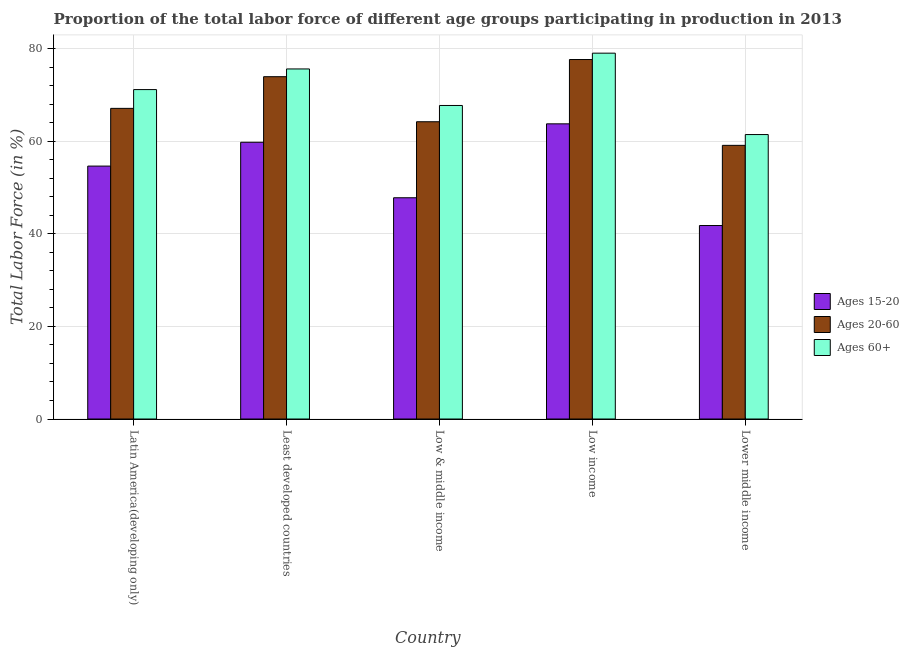Are the number of bars per tick equal to the number of legend labels?
Offer a terse response. Yes. How many bars are there on the 2nd tick from the left?
Ensure brevity in your answer.  3. In how many cases, is the number of bars for a given country not equal to the number of legend labels?
Give a very brief answer. 0. What is the percentage of labor force within the age group 15-20 in Lower middle income?
Keep it short and to the point. 41.79. Across all countries, what is the maximum percentage of labor force above age 60?
Make the answer very short. 79.02. Across all countries, what is the minimum percentage of labor force within the age group 15-20?
Keep it short and to the point. 41.79. In which country was the percentage of labor force within the age group 15-20 maximum?
Ensure brevity in your answer.  Low income. In which country was the percentage of labor force above age 60 minimum?
Provide a short and direct response. Lower middle income. What is the total percentage of labor force within the age group 20-60 in the graph?
Offer a very short reply. 341.98. What is the difference between the percentage of labor force within the age group 20-60 in Latin America(developing only) and that in Low income?
Ensure brevity in your answer.  -10.55. What is the difference between the percentage of labor force within the age group 15-20 in Latin America(developing only) and the percentage of labor force within the age group 20-60 in Low & middle income?
Make the answer very short. -9.58. What is the average percentage of labor force within the age group 15-20 per country?
Make the answer very short. 53.55. What is the difference between the percentage of labor force within the age group 20-60 and percentage of labor force within the age group 15-20 in Lower middle income?
Offer a very short reply. 17.31. What is the ratio of the percentage of labor force within the age group 20-60 in Least developed countries to that in Low & middle income?
Your answer should be compact. 1.15. What is the difference between the highest and the second highest percentage of labor force within the age group 15-20?
Provide a short and direct response. 3.98. What is the difference between the highest and the lowest percentage of labor force above age 60?
Provide a short and direct response. 17.58. Is the sum of the percentage of labor force within the age group 15-20 in Low & middle income and Lower middle income greater than the maximum percentage of labor force within the age group 20-60 across all countries?
Give a very brief answer. Yes. What does the 2nd bar from the left in Low & middle income represents?
Make the answer very short. Ages 20-60. What does the 3rd bar from the right in Low & middle income represents?
Make the answer very short. Ages 15-20. Are all the bars in the graph horizontal?
Ensure brevity in your answer.  No. Are the values on the major ticks of Y-axis written in scientific E-notation?
Your answer should be very brief. No. Does the graph contain grids?
Your answer should be compact. Yes. Where does the legend appear in the graph?
Offer a very short reply. Center right. What is the title of the graph?
Your answer should be very brief. Proportion of the total labor force of different age groups participating in production in 2013. What is the label or title of the Y-axis?
Give a very brief answer. Total Labor Force (in %). What is the Total Labor Force (in %) in Ages 15-20 in Latin America(developing only)?
Your answer should be compact. 54.63. What is the Total Labor Force (in %) of Ages 20-60 in Latin America(developing only)?
Keep it short and to the point. 67.1. What is the Total Labor Force (in %) of Ages 60+ in Latin America(developing only)?
Your answer should be compact. 71.15. What is the Total Labor Force (in %) in Ages 15-20 in Least developed countries?
Your answer should be very brief. 59.77. What is the Total Labor Force (in %) in Ages 20-60 in Least developed countries?
Your answer should be compact. 73.93. What is the Total Labor Force (in %) in Ages 60+ in Least developed countries?
Offer a very short reply. 75.61. What is the Total Labor Force (in %) in Ages 15-20 in Low & middle income?
Your answer should be compact. 47.79. What is the Total Labor Force (in %) of Ages 20-60 in Low & middle income?
Ensure brevity in your answer.  64.2. What is the Total Labor Force (in %) of Ages 60+ in Low & middle income?
Provide a succinct answer. 67.72. What is the Total Labor Force (in %) of Ages 15-20 in Low income?
Give a very brief answer. 63.75. What is the Total Labor Force (in %) in Ages 20-60 in Low income?
Offer a terse response. 77.64. What is the Total Labor Force (in %) in Ages 60+ in Low income?
Provide a short and direct response. 79.02. What is the Total Labor Force (in %) in Ages 15-20 in Lower middle income?
Ensure brevity in your answer.  41.79. What is the Total Labor Force (in %) of Ages 20-60 in Lower middle income?
Provide a succinct answer. 59.11. What is the Total Labor Force (in %) in Ages 60+ in Lower middle income?
Your response must be concise. 61.44. Across all countries, what is the maximum Total Labor Force (in %) in Ages 15-20?
Make the answer very short. 63.75. Across all countries, what is the maximum Total Labor Force (in %) of Ages 20-60?
Provide a succinct answer. 77.64. Across all countries, what is the maximum Total Labor Force (in %) in Ages 60+?
Provide a short and direct response. 79.02. Across all countries, what is the minimum Total Labor Force (in %) of Ages 15-20?
Your answer should be very brief. 41.79. Across all countries, what is the minimum Total Labor Force (in %) in Ages 20-60?
Make the answer very short. 59.11. Across all countries, what is the minimum Total Labor Force (in %) of Ages 60+?
Provide a short and direct response. 61.44. What is the total Total Labor Force (in %) of Ages 15-20 in the graph?
Provide a short and direct response. 267.73. What is the total Total Labor Force (in %) of Ages 20-60 in the graph?
Your response must be concise. 341.98. What is the total Total Labor Force (in %) of Ages 60+ in the graph?
Your response must be concise. 354.93. What is the difference between the Total Labor Force (in %) in Ages 15-20 in Latin America(developing only) and that in Least developed countries?
Your answer should be very brief. -5.15. What is the difference between the Total Labor Force (in %) in Ages 20-60 in Latin America(developing only) and that in Least developed countries?
Your answer should be very brief. -6.84. What is the difference between the Total Labor Force (in %) of Ages 60+ in Latin America(developing only) and that in Least developed countries?
Provide a short and direct response. -4.46. What is the difference between the Total Labor Force (in %) of Ages 15-20 in Latin America(developing only) and that in Low & middle income?
Provide a succinct answer. 6.84. What is the difference between the Total Labor Force (in %) of Ages 20-60 in Latin America(developing only) and that in Low & middle income?
Offer a terse response. 2.89. What is the difference between the Total Labor Force (in %) in Ages 60+ in Latin America(developing only) and that in Low & middle income?
Provide a short and direct response. 3.43. What is the difference between the Total Labor Force (in %) in Ages 15-20 in Latin America(developing only) and that in Low income?
Ensure brevity in your answer.  -9.12. What is the difference between the Total Labor Force (in %) of Ages 20-60 in Latin America(developing only) and that in Low income?
Keep it short and to the point. -10.55. What is the difference between the Total Labor Force (in %) of Ages 60+ in Latin America(developing only) and that in Low income?
Provide a succinct answer. -7.87. What is the difference between the Total Labor Force (in %) of Ages 15-20 in Latin America(developing only) and that in Lower middle income?
Offer a terse response. 12.84. What is the difference between the Total Labor Force (in %) in Ages 20-60 in Latin America(developing only) and that in Lower middle income?
Provide a succinct answer. 7.99. What is the difference between the Total Labor Force (in %) in Ages 60+ in Latin America(developing only) and that in Lower middle income?
Your response must be concise. 9.71. What is the difference between the Total Labor Force (in %) of Ages 15-20 in Least developed countries and that in Low & middle income?
Your answer should be compact. 11.99. What is the difference between the Total Labor Force (in %) of Ages 20-60 in Least developed countries and that in Low & middle income?
Provide a succinct answer. 9.73. What is the difference between the Total Labor Force (in %) of Ages 60+ in Least developed countries and that in Low & middle income?
Offer a very short reply. 7.89. What is the difference between the Total Labor Force (in %) of Ages 15-20 in Least developed countries and that in Low income?
Your answer should be compact. -3.98. What is the difference between the Total Labor Force (in %) in Ages 20-60 in Least developed countries and that in Low income?
Your response must be concise. -3.71. What is the difference between the Total Labor Force (in %) of Ages 60+ in Least developed countries and that in Low income?
Ensure brevity in your answer.  -3.41. What is the difference between the Total Labor Force (in %) in Ages 15-20 in Least developed countries and that in Lower middle income?
Ensure brevity in your answer.  17.98. What is the difference between the Total Labor Force (in %) in Ages 20-60 in Least developed countries and that in Lower middle income?
Provide a succinct answer. 14.83. What is the difference between the Total Labor Force (in %) in Ages 60+ in Least developed countries and that in Lower middle income?
Offer a very short reply. 14.17. What is the difference between the Total Labor Force (in %) of Ages 15-20 in Low & middle income and that in Low income?
Offer a very short reply. -15.96. What is the difference between the Total Labor Force (in %) in Ages 20-60 in Low & middle income and that in Low income?
Provide a short and direct response. -13.44. What is the difference between the Total Labor Force (in %) of Ages 60+ in Low & middle income and that in Low income?
Offer a very short reply. -11.3. What is the difference between the Total Labor Force (in %) in Ages 15-20 in Low & middle income and that in Lower middle income?
Offer a terse response. 6. What is the difference between the Total Labor Force (in %) in Ages 20-60 in Low & middle income and that in Lower middle income?
Offer a very short reply. 5.1. What is the difference between the Total Labor Force (in %) in Ages 60+ in Low & middle income and that in Lower middle income?
Your answer should be compact. 6.28. What is the difference between the Total Labor Force (in %) in Ages 15-20 in Low income and that in Lower middle income?
Your response must be concise. 21.96. What is the difference between the Total Labor Force (in %) in Ages 20-60 in Low income and that in Lower middle income?
Your answer should be very brief. 18.54. What is the difference between the Total Labor Force (in %) of Ages 60+ in Low income and that in Lower middle income?
Offer a very short reply. 17.58. What is the difference between the Total Labor Force (in %) of Ages 15-20 in Latin America(developing only) and the Total Labor Force (in %) of Ages 20-60 in Least developed countries?
Provide a short and direct response. -19.31. What is the difference between the Total Labor Force (in %) of Ages 15-20 in Latin America(developing only) and the Total Labor Force (in %) of Ages 60+ in Least developed countries?
Make the answer very short. -20.98. What is the difference between the Total Labor Force (in %) in Ages 20-60 in Latin America(developing only) and the Total Labor Force (in %) in Ages 60+ in Least developed countries?
Ensure brevity in your answer.  -8.51. What is the difference between the Total Labor Force (in %) in Ages 15-20 in Latin America(developing only) and the Total Labor Force (in %) in Ages 20-60 in Low & middle income?
Your answer should be compact. -9.58. What is the difference between the Total Labor Force (in %) of Ages 15-20 in Latin America(developing only) and the Total Labor Force (in %) of Ages 60+ in Low & middle income?
Make the answer very short. -13.09. What is the difference between the Total Labor Force (in %) of Ages 20-60 in Latin America(developing only) and the Total Labor Force (in %) of Ages 60+ in Low & middle income?
Offer a terse response. -0.62. What is the difference between the Total Labor Force (in %) of Ages 15-20 in Latin America(developing only) and the Total Labor Force (in %) of Ages 20-60 in Low income?
Provide a short and direct response. -23.02. What is the difference between the Total Labor Force (in %) of Ages 15-20 in Latin America(developing only) and the Total Labor Force (in %) of Ages 60+ in Low income?
Offer a very short reply. -24.39. What is the difference between the Total Labor Force (in %) of Ages 20-60 in Latin America(developing only) and the Total Labor Force (in %) of Ages 60+ in Low income?
Keep it short and to the point. -11.92. What is the difference between the Total Labor Force (in %) of Ages 15-20 in Latin America(developing only) and the Total Labor Force (in %) of Ages 20-60 in Lower middle income?
Give a very brief answer. -4.48. What is the difference between the Total Labor Force (in %) in Ages 15-20 in Latin America(developing only) and the Total Labor Force (in %) in Ages 60+ in Lower middle income?
Your answer should be compact. -6.81. What is the difference between the Total Labor Force (in %) of Ages 20-60 in Latin America(developing only) and the Total Labor Force (in %) of Ages 60+ in Lower middle income?
Offer a very short reply. 5.66. What is the difference between the Total Labor Force (in %) of Ages 15-20 in Least developed countries and the Total Labor Force (in %) of Ages 20-60 in Low & middle income?
Give a very brief answer. -4.43. What is the difference between the Total Labor Force (in %) in Ages 15-20 in Least developed countries and the Total Labor Force (in %) in Ages 60+ in Low & middle income?
Your answer should be compact. -7.94. What is the difference between the Total Labor Force (in %) in Ages 20-60 in Least developed countries and the Total Labor Force (in %) in Ages 60+ in Low & middle income?
Your answer should be compact. 6.22. What is the difference between the Total Labor Force (in %) of Ages 15-20 in Least developed countries and the Total Labor Force (in %) of Ages 20-60 in Low income?
Offer a terse response. -17.87. What is the difference between the Total Labor Force (in %) of Ages 15-20 in Least developed countries and the Total Labor Force (in %) of Ages 60+ in Low income?
Your response must be concise. -19.24. What is the difference between the Total Labor Force (in %) in Ages 20-60 in Least developed countries and the Total Labor Force (in %) in Ages 60+ in Low income?
Make the answer very short. -5.08. What is the difference between the Total Labor Force (in %) in Ages 15-20 in Least developed countries and the Total Labor Force (in %) in Ages 20-60 in Lower middle income?
Give a very brief answer. 0.67. What is the difference between the Total Labor Force (in %) in Ages 15-20 in Least developed countries and the Total Labor Force (in %) in Ages 60+ in Lower middle income?
Ensure brevity in your answer.  -1.66. What is the difference between the Total Labor Force (in %) in Ages 20-60 in Least developed countries and the Total Labor Force (in %) in Ages 60+ in Lower middle income?
Provide a succinct answer. 12.5. What is the difference between the Total Labor Force (in %) in Ages 15-20 in Low & middle income and the Total Labor Force (in %) in Ages 20-60 in Low income?
Keep it short and to the point. -29.86. What is the difference between the Total Labor Force (in %) of Ages 15-20 in Low & middle income and the Total Labor Force (in %) of Ages 60+ in Low income?
Give a very brief answer. -31.23. What is the difference between the Total Labor Force (in %) in Ages 20-60 in Low & middle income and the Total Labor Force (in %) in Ages 60+ in Low income?
Provide a short and direct response. -14.81. What is the difference between the Total Labor Force (in %) in Ages 15-20 in Low & middle income and the Total Labor Force (in %) in Ages 20-60 in Lower middle income?
Your answer should be very brief. -11.32. What is the difference between the Total Labor Force (in %) in Ages 15-20 in Low & middle income and the Total Labor Force (in %) in Ages 60+ in Lower middle income?
Your answer should be very brief. -13.65. What is the difference between the Total Labor Force (in %) in Ages 20-60 in Low & middle income and the Total Labor Force (in %) in Ages 60+ in Lower middle income?
Your answer should be very brief. 2.77. What is the difference between the Total Labor Force (in %) of Ages 15-20 in Low income and the Total Labor Force (in %) of Ages 20-60 in Lower middle income?
Ensure brevity in your answer.  4.65. What is the difference between the Total Labor Force (in %) of Ages 15-20 in Low income and the Total Labor Force (in %) of Ages 60+ in Lower middle income?
Make the answer very short. 2.31. What is the difference between the Total Labor Force (in %) of Ages 20-60 in Low income and the Total Labor Force (in %) of Ages 60+ in Lower middle income?
Your answer should be very brief. 16.21. What is the average Total Labor Force (in %) in Ages 15-20 per country?
Offer a very short reply. 53.55. What is the average Total Labor Force (in %) in Ages 20-60 per country?
Ensure brevity in your answer.  68.4. What is the average Total Labor Force (in %) in Ages 60+ per country?
Your response must be concise. 70.99. What is the difference between the Total Labor Force (in %) of Ages 15-20 and Total Labor Force (in %) of Ages 20-60 in Latin America(developing only)?
Give a very brief answer. -12.47. What is the difference between the Total Labor Force (in %) in Ages 15-20 and Total Labor Force (in %) in Ages 60+ in Latin America(developing only)?
Provide a succinct answer. -16.52. What is the difference between the Total Labor Force (in %) in Ages 20-60 and Total Labor Force (in %) in Ages 60+ in Latin America(developing only)?
Keep it short and to the point. -4.05. What is the difference between the Total Labor Force (in %) in Ages 15-20 and Total Labor Force (in %) in Ages 20-60 in Least developed countries?
Offer a very short reply. -14.16. What is the difference between the Total Labor Force (in %) in Ages 15-20 and Total Labor Force (in %) in Ages 60+ in Least developed countries?
Keep it short and to the point. -15.83. What is the difference between the Total Labor Force (in %) of Ages 20-60 and Total Labor Force (in %) of Ages 60+ in Least developed countries?
Make the answer very short. -1.67. What is the difference between the Total Labor Force (in %) of Ages 15-20 and Total Labor Force (in %) of Ages 20-60 in Low & middle income?
Make the answer very short. -16.42. What is the difference between the Total Labor Force (in %) in Ages 15-20 and Total Labor Force (in %) in Ages 60+ in Low & middle income?
Give a very brief answer. -19.93. What is the difference between the Total Labor Force (in %) in Ages 20-60 and Total Labor Force (in %) in Ages 60+ in Low & middle income?
Keep it short and to the point. -3.51. What is the difference between the Total Labor Force (in %) of Ages 15-20 and Total Labor Force (in %) of Ages 20-60 in Low income?
Offer a terse response. -13.89. What is the difference between the Total Labor Force (in %) in Ages 15-20 and Total Labor Force (in %) in Ages 60+ in Low income?
Offer a terse response. -15.26. What is the difference between the Total Labor Force (in %) of Ages 20-60 and Total Labor Force (in %) of Ages 60+ in Low income?
Ensure brevity in your answer.  -1.37. What is the difference between the Total Labor Force (in %) in Ages 15-20 and Total Labor Force (in %) in Ages 20-60 in Lower middle income?
Provide a succinct answer. -17.31. What is the difference between the Total Labor Force (in %) of Ages 15-20 and Total Labor Force (in %) of Ages 60+ in Lower middle income?
Your answer should be very brief. -19.65. What is the difference between the Total Labor Force (in %) in Ages 20-60 and Total Labor Force (in %) in Ages 60+ in Lower middle income?
Your response must be concise. -2.33. What is the ratio of the Total Labor Force (in %) in Ages 15-20 in Latin America(developing only) to that in Least developed countries?
Offer a terse response. 0.91. What is the ratio of the Total Labor Force (in %) of Ages 20-60 in Latin America(developing only) to that in Least developed countries?
Give a very brief answer. 0.91. What is the ratio of the Total Labor Force (in %) in Ages 60+ in Latin America(developing only) to that in Least developed countries?
Provide a succinct answer. 0.94. What is the ratio of the Total Labor Force (in %) in Ages 15-20 in Latin America(developing only) to that in Low & middle income?
Give a very brief answer. 1.14. What is the ratio of the Total Labor Force (in %) of Ages 20-60 in Latin America(developing only) to that in Low & middle income?
Offer a terse response. 1.04. What is the ratio of the Total Labor Force (in %) in Ages 60+ in Latin America(developing only) to that in Low & middle income?
Make the answer very short. 1.05. What is the ratio of the Total Labor Force (in %) of Ages 15-20 in Latin America(developing only) to that in Low income?
Offer a terse response. 0.86. What is the ratio of the Total Labor Force (in %) in Ages 20-60 in Latin America(developing only) to that in Low income?
Make the answer very short. 0.86. What is the ratio of the Total Labor Force (in %) of Ages 60+ in Latin America(developing only) to that in Low income?
Provide a short and direct response. 0.9. What is the ratio of the Total Labor Force (in %) of Ages 15-20 in Latin America(developing only) to that in Lower middle income?
Offer a terse response. 1.31. What is the ratio of the Total Labor Force (in %) in Ages 20-60 in Latin America(developing only) to that in Lower middle income?
Make the answer very short. 1.14. What is the ratio of the Total Labor Force (in %) of Ages 60+ in Latin America(developing only) to that in Lower middle income?
Offer a very short reply. 1.16. What is the ratio of the Total Labor Force (in %) of Ages 15-20 in Least developed countries to that in Low & middle income?
Your answer should be compact. 1.25. What is the ratio of the Total Labor Force (in %) in Ages 20-60 in Least developed countries to that in Low & middle income?
Your answer should be very brief. 1.15. What is the ratio of the Total Labor Force (in %) in Ages 60+ in Least developed countries to that in Low & middle income?
Your answer should be compact. 1.12. What is the ratio of the Total Labor Force (in %) of Ages 15-20 in Least developed countries to that in Low income?
Ensure brevity in your answer.  0.94. What is the ratio of the Total Labor Force (in %) in Ages 20-60 in Least developed countries to that in Low income?
Your answer should be compact. 0.95. What is the ratio of the Total Labor Force (in %) of Ages 60+ in Least developed countries to that in Low income?
Provide a succinct answer. 0.96. What is the ratio of the Total Labor Force (in %) of Ages 15-20 in Least developed countries to that in Lower middle income?
Provide a short and direct response. 1.43. What is the ratio of the Total Labor Force (in %) of Ages 20-60 in Least developed countries to that in Lower middle income?
Keep it short and to the point. 1.25. What is the ratio of the Total Labor Force (in %) in Ages 60+ in Least developed countries to that in Lower middle income?
Ensure brevity in your answer.  1.23. What is the ratio of the Total Labor Force (in %) of Ages 15-20 in Low & middle income to that in Low income?
Your answer should be very brief. 0.75. What is the ratio of the Total Labor Force (in %) in Ages 20-60 in Low & middle income to that in Low income?
Provide a succinct answer. 0.83. What is the ratio of the Total Labor Force (in %) in Ages 60+ in Low & middle income to that in Low income?
Offer a terse response. 0.86. What is the ratio of the Total Labor Force (in %) of Ages 15-20 in Low & middle income to that in Lower middle income?
Offer a very short reply. 1.14. What is the ratio of the Total Labor Force (in %) in Ages 20-60 in Low & middle income to that in Lower middle income?
Give a very brief answer. 1.09. What is the ratio of the Total Labor Force (in %) of Ages 60+ in Low & middle income to that in Lower middle income?
Your answer should be compact. 1.1. What is the ratio of the Total Labor Force (in %) of Ages 15-20 in Low income to that in Lower middle income?
Give a very brief answer. 1.53. What is the ratio of the Total Labor Force (in %) of Ages 20-60 in Low income to that in Lower middle income?
Your answer should be very brief. 1.31. What is the ratio of the Total Labor Force (in %) of Ages 60+ in Low income to that in Lower middle income?
Your response must be concise. 1.29. What is the difference between the highest and the second highest Total Labor Force (in %) in Ages 15-20?
Provide a short and direct response. 3.98. What is the difference between the highest and the second highest Total Labor Force (in %) of Ages 20-60?
Offer a terse response. 3.71. What is the difference between the highest and the second highest Total Labor Force (in %) in Ages 60+?
Offer a terse response. 3.41. What is the difference between the highest and the lowest Total Labor Force (in %) in Ages 15-20?
Offer a terse response. 21.96. What is the difference between the highest and the lowest Total Labor Force (in %) in Ages 20-60?
Your answer should be compact. 18.54. What is the difference between the highest and the lowest Total Labor Force (in %) of Ages 60+?
Make the answer very short. 17.58. 